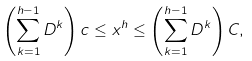<formula> <loc_0><loc_0><loc_500><loc_500>\left ( \sum _ { k = 1 } ^ { h - 1 } D ^ { k } \right ) c \leq x ^ { h } \leq \left ( \sum _ { k = 1 } ^ { h - 1 } D ^ { k } \right ) C ,</formula> 